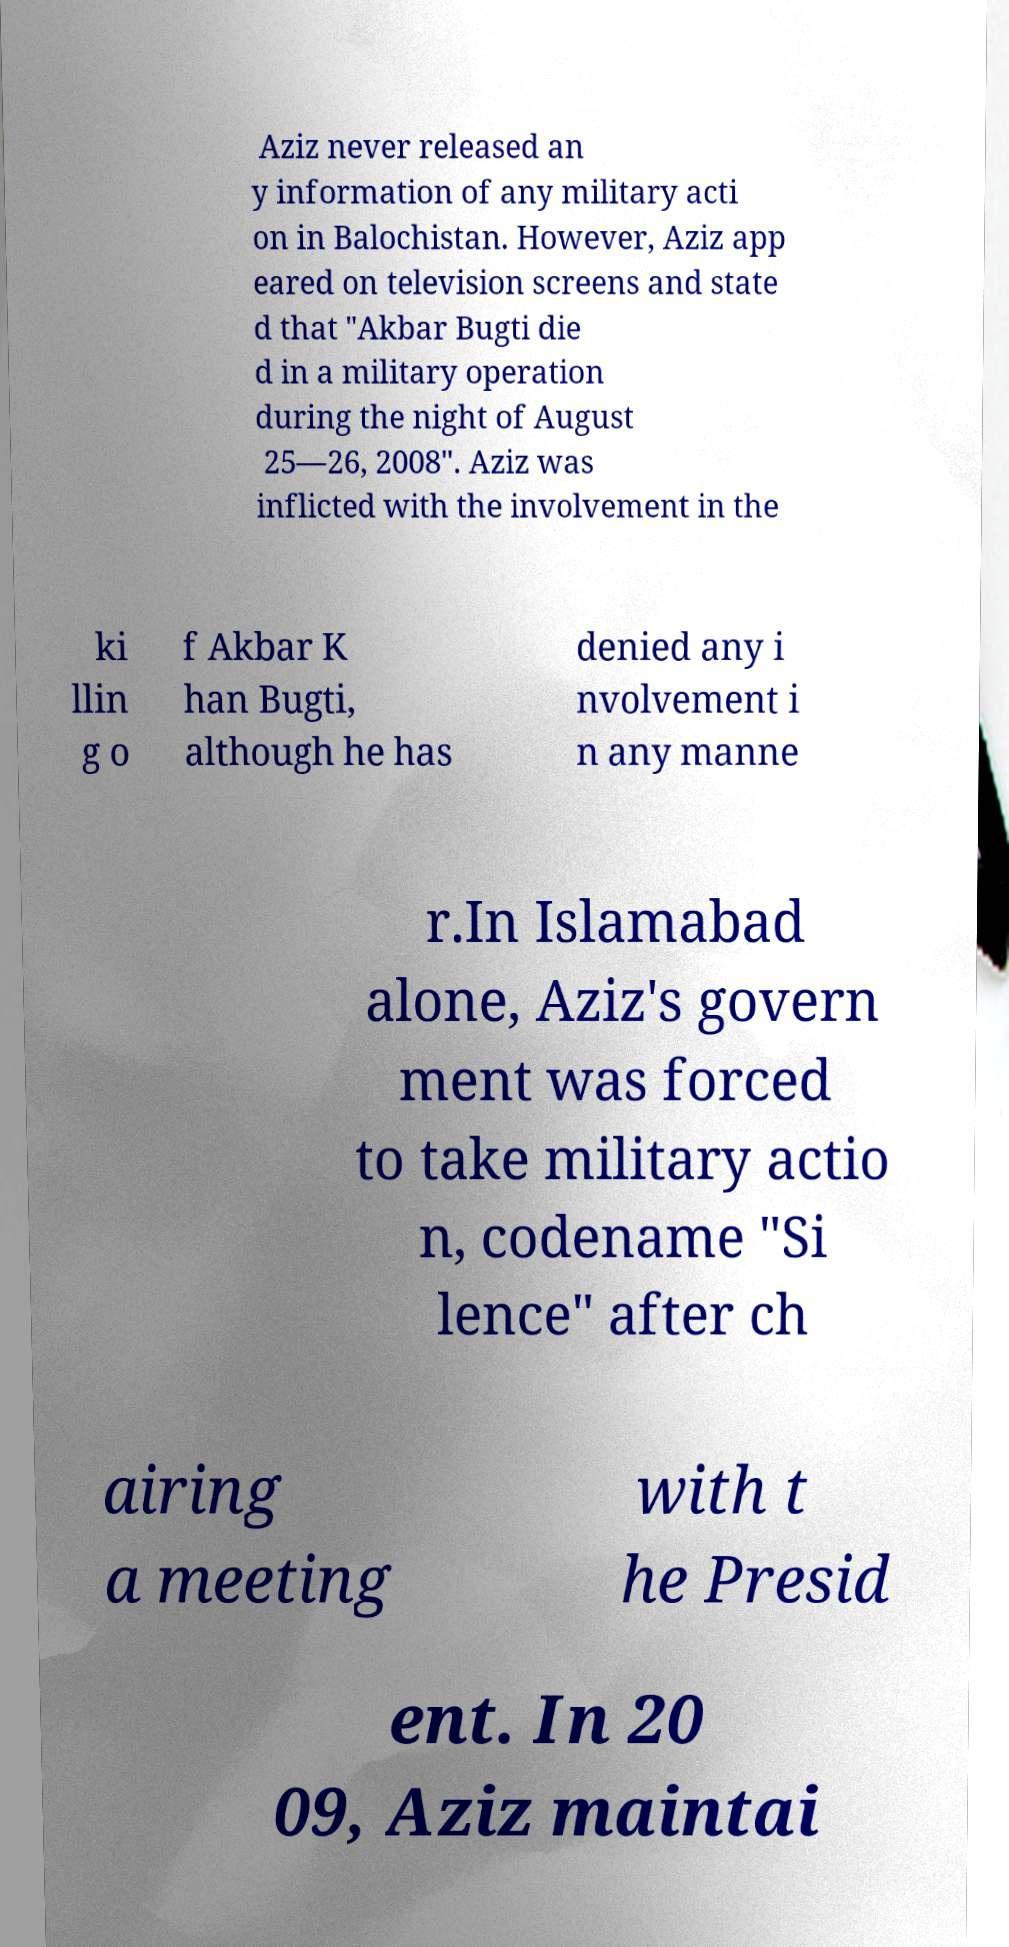What messages or text are displayed in this image? I need them in a readable, typed format. Aziz never released an y information of any military acti on in Balochistan. However, Aziz app eared on television screens and state d that "Akbar Bugti die d in a military operation during the night of August 25—26, 2008". Aziz was inflicted with the involvement in the ki llin g o f Akbar K han Bugti, although he has denied any i nvolvement i n any manne r.In Islamabad alone, Aziz's govern ment was forced to take military actio n, codename "Si lence" after ch airing a meeting with t he Presid ent. In 20 09, Aziz maintai 